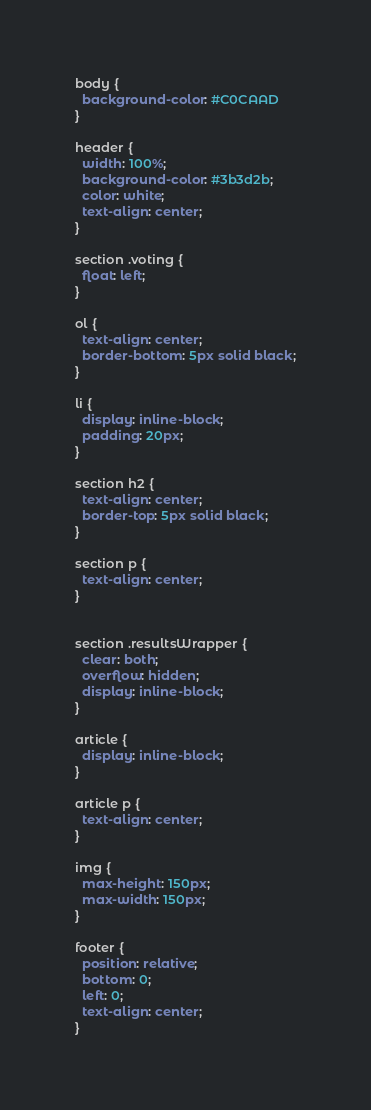Convert code to text. <code><loc_0><loc_0><loc_500><loc_500><_CSS_>body {
  background-color: #C0CAAD
}

header {
  width: 100%;
  background-color: #3b3d2b;
  color: white;
  text-align: center;
}

section .voting {
  float: left;
}

ol {
  text-align: center;
  border-bottom: 5px solid black;
}

li {
  display: inline-block;
  padding: 20px;
}

section h2 {
  text-align: center;
  border-top: 5px solid black;
}

section p {
  text-align: center;
}


section .resultsWrapper {
  clear: both;
  overflow: hidden;
  display: inline-block;
}

article {
  display: inline-block;
}

article p {
  text-align: center;
}

img {
  max-height: 150px;
  max-width: 150px;
}

footer {
  position: relative;
  bottom: 0;
  left: 0;
  text-align: center;
}

</code> 